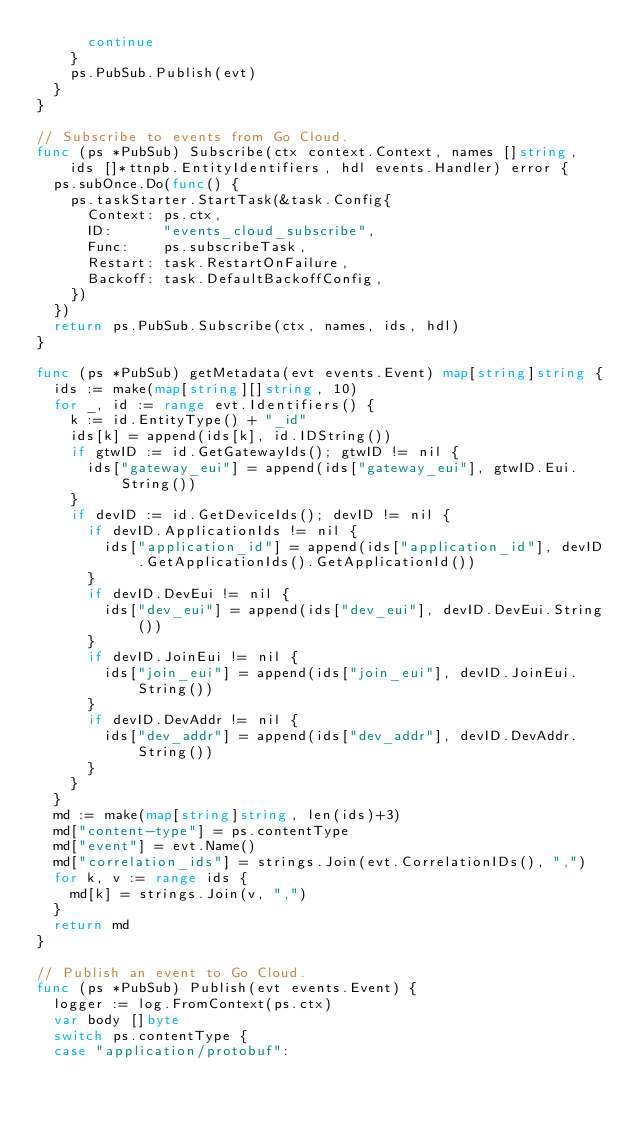<code> <loc_0><loc_0><loc_500><loc_500><_Go_>			continue
		}
		ps.PubSub.Publish(evt)
	}
}

// Subscribe to events from Go Cloud.
func (ps *PubSub) Subscribe(ctx context.Context, names []string, ids []*ttnpb.EntityIdentifiers, hdl events.Handler) error {
	ps.subOnce.Do(func() {
		ps.taskStarter.StartTask(&task.Config{
			Context: ps.ctx,
			ID:      "events_cloud_subscribe",
			Func:    ps.subscribeTask,
			Restart: task.RestartOnFailure,
			Backoff: task.DefaultBackoffConfig,
		})
	})
	return ps.PubSub.Subscribe(ctx, names, ids, hdl)
}

func (ps *PubSub) getMetadata(evt events.Event) map[string]string {
	ids := make(map[string][]string, 10)
	for _, id := range evt.Identifiers() {
		k := id.EntityType() + "_id"
		ids[k] = append(ids[k], id.IDString())
		if gtwID := id.GetGatewayIds(); gtwID != nil {
			ids["gateway_eui"] = append(ids["gateway_eui"], gtwID.Eui.String())
		}
		if devID := id.GetDeviceIds(); devID != nil {
			if devID.ApplicationIds != nil {
				ids["application_id"] = append(ids["application_id"], devID.GetApplicationIds().GetApplicationId())
			}
			if devID.DevEui != nil {
				ids["dev_eui"] = append(ids["dev_eui"], devID.DevEui.String())
			}
			if devID.JoinEui != nil {
				ids["join_eui"] = append(ids["join_eui"], devID.JoinEui.String())
			}
			if devID.DevAddr != nil {
				ids["dev_addr"] = append(ids["dev_addr"], devID.DevAddr.String())
			}
		}
	}
	md := make(map[string]string, len(ids)+3)
	md["content-type"] = ps.contentType
	md["event"] = evt.Name()
	md["correlation_ids"] = strings.Join(evt.CorrelationIDs(), ",")
	for k, v := range ids {
		md[k] = strings.Join(v, ",")
	}
	return md
}

// Publish an event to Go Cloud.
func (ps *PubSub) Publish(evt events.Event) {
	logger := log.FromContext(ps.ctx)
	var body []byte
	switch ps.contentType {
	case "application/protobuf":</code> 